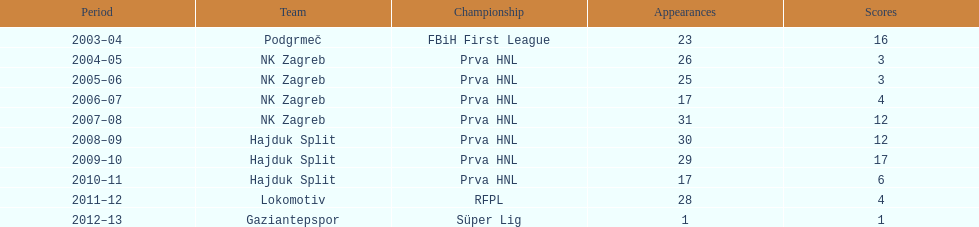After scoring against bulgaria in zenica, ibricic also scored against this team in a 7-0 victory in zenica less then a month after the friendly match against bulgaria. Estonia. 